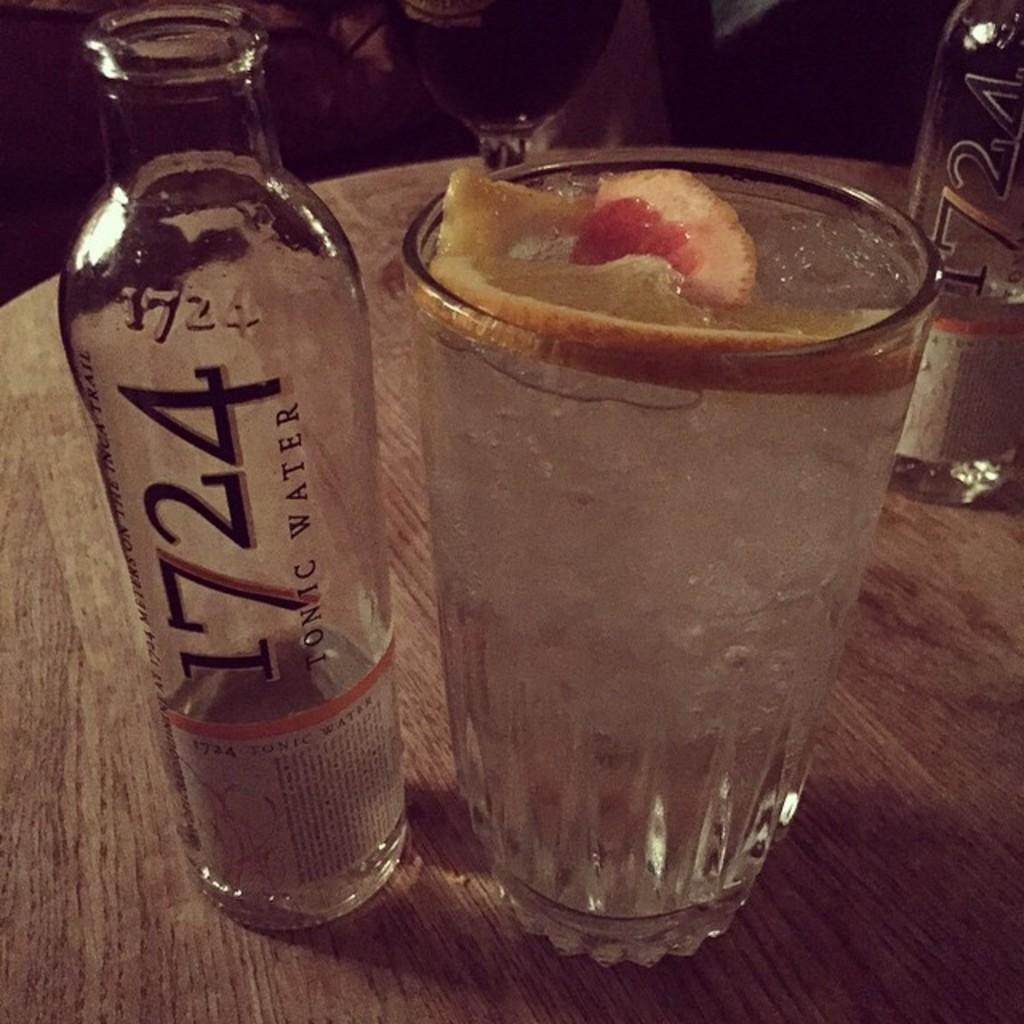<image>
Share a concise interpretation of the image provided. Empty bottle of 1724 tonic water sits on a wooden table next to a glass with fruit in it. 